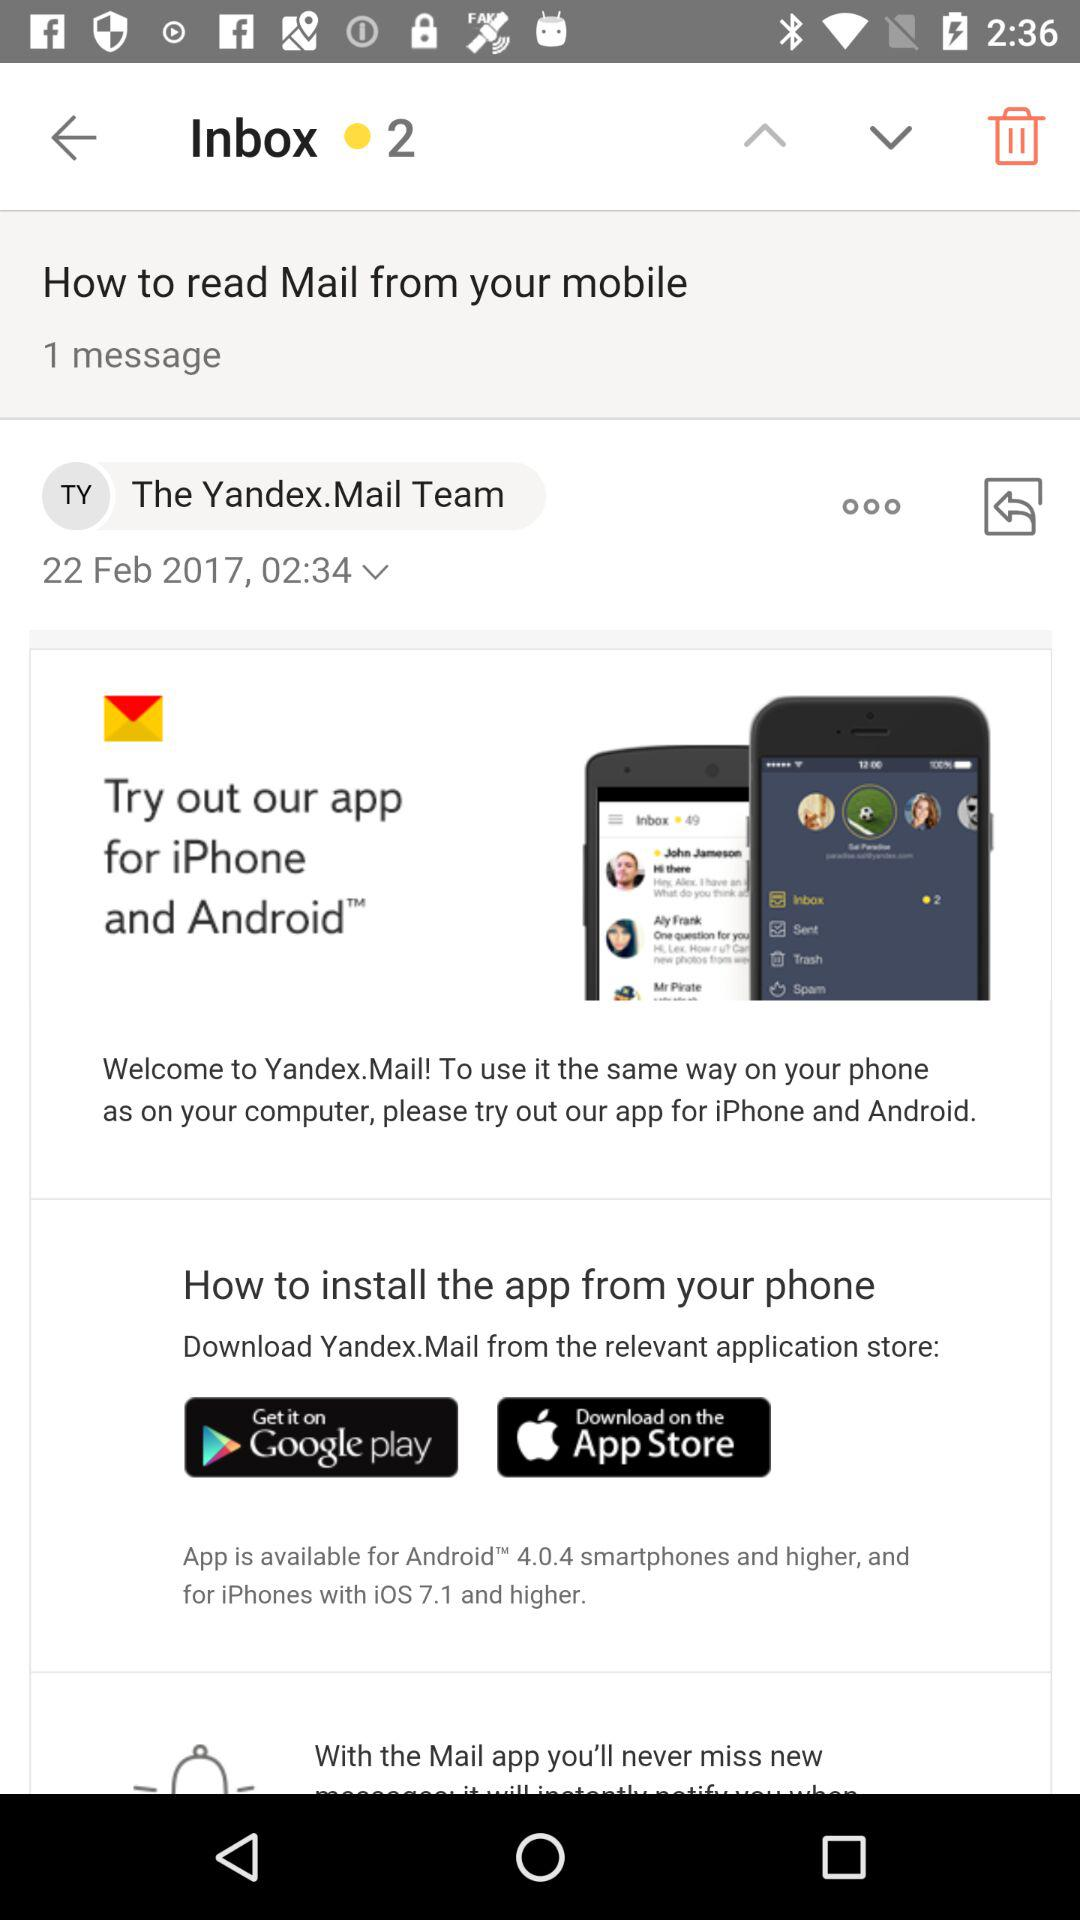How many messages are in the inbox?
Answer the question using a single word or phrase. 1 